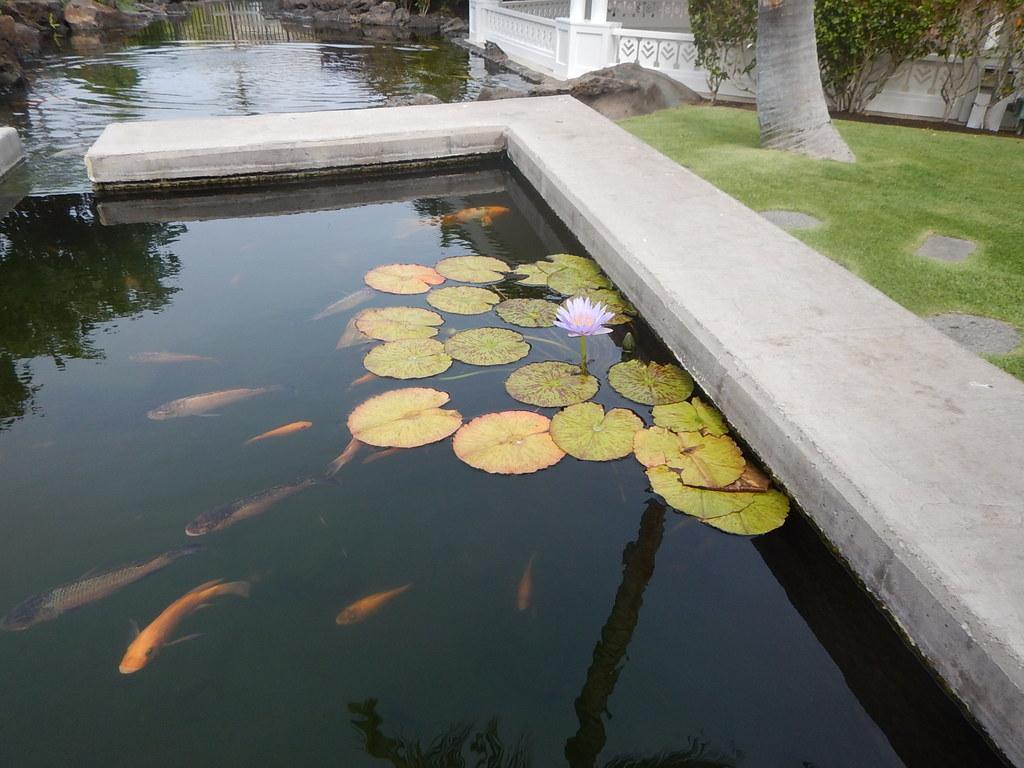Could you give a brief overview of what you see in this image? In front of the image there are fish in the water. And there are leaves floating on the water. And also there is a flower. On the right side of the image on the ground there is grass. And also there are plants and there is a tree trunk. Behind them there are railings and poles. In the background there are rocks. 